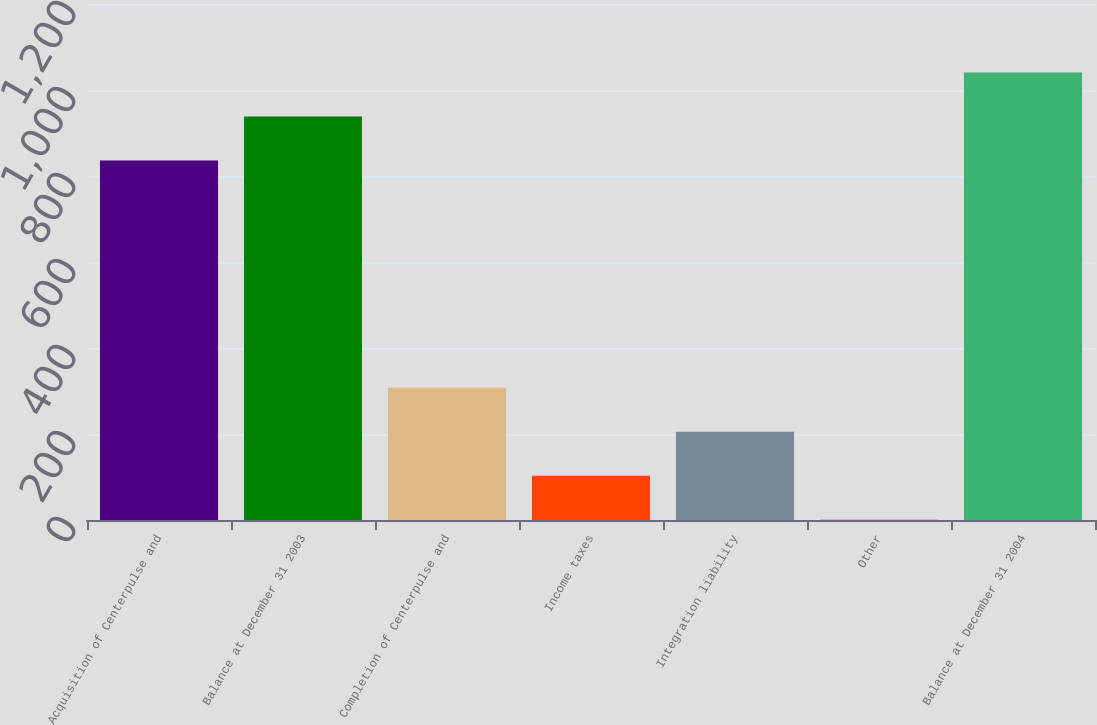Convert chart to OTSL. <chart><loc_0><loc_0><loc_500><loc_500><bar_chart><fcel>Acquisition of Centerpulse and<fcel>Balance at December 31 2003<fcel>Completion of Centerpulse and<fcel>Income taxes<fcel>Integration liability<fcel>Other<fcel>Balance at December 31 2004<nl><fcel>836.3<fcel>938.54<fcel>307.52<fcel>103.04<fcel>205.28<fcel>0.8<fcel>1040.78<nl></chart> 